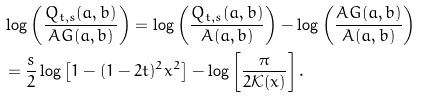Convert formula to latex. <formula><loc_0><loc_0><loc_500><loc_500>& \log \left ( \frac { Q _ { t , s } ( a , b ) } { A G ( a , b ) } \right ) = \log \left ( \frac { Q _ { t , s } ( a , b ) } { A ( a , b ) } \right ) - \log \left ( \frac { A G ( a , b ) } { A ( a , b ) } \right ) \\ & = \frac { s } { 2 } \log \left [ 1 - ( 1 - 2 t ) ^ { 2 } x ^ { 2 } \right ] - \log \left [ \frac { \pi } { 2 \mathcal { K } ( x ) } \right ] .</formula> 